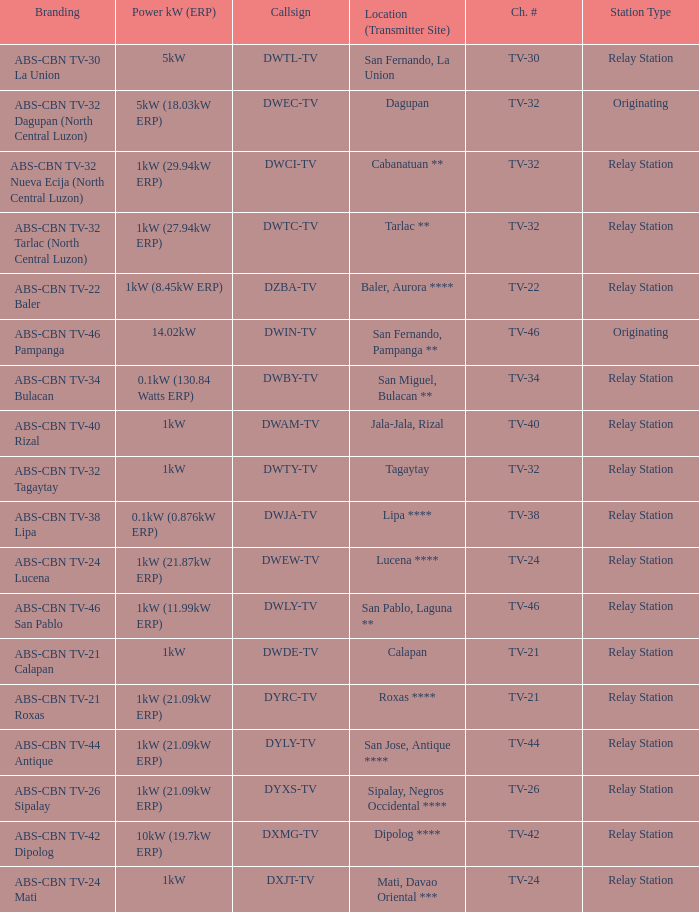What is the branding of the callsign DWCI-TV? ABS-CBN TV-32 Nueva Ecija (North Central Luzon). 